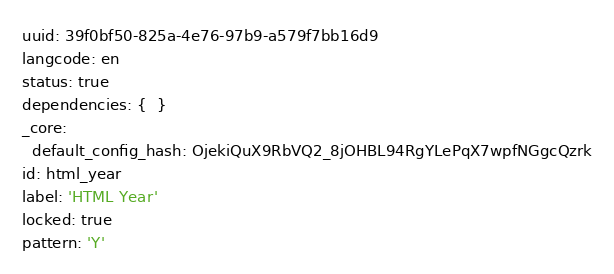Convert code to text. <code><loc_0><loc_0><loc_500><loc_500><_YAML_>uuid: 39f0bf50-825a-4e76-97b9-a579f7bb16d9
langcode: en
status: true
dependencies: {  }
_core:
  default_config_hash: OjekiQuX9RbVQ2_8jOHBL94RgYLePqX7wpfNGgcQzrk
id: html_year
label: 'HTML Year'
locked: true
pattern: 'Y'
</code> 